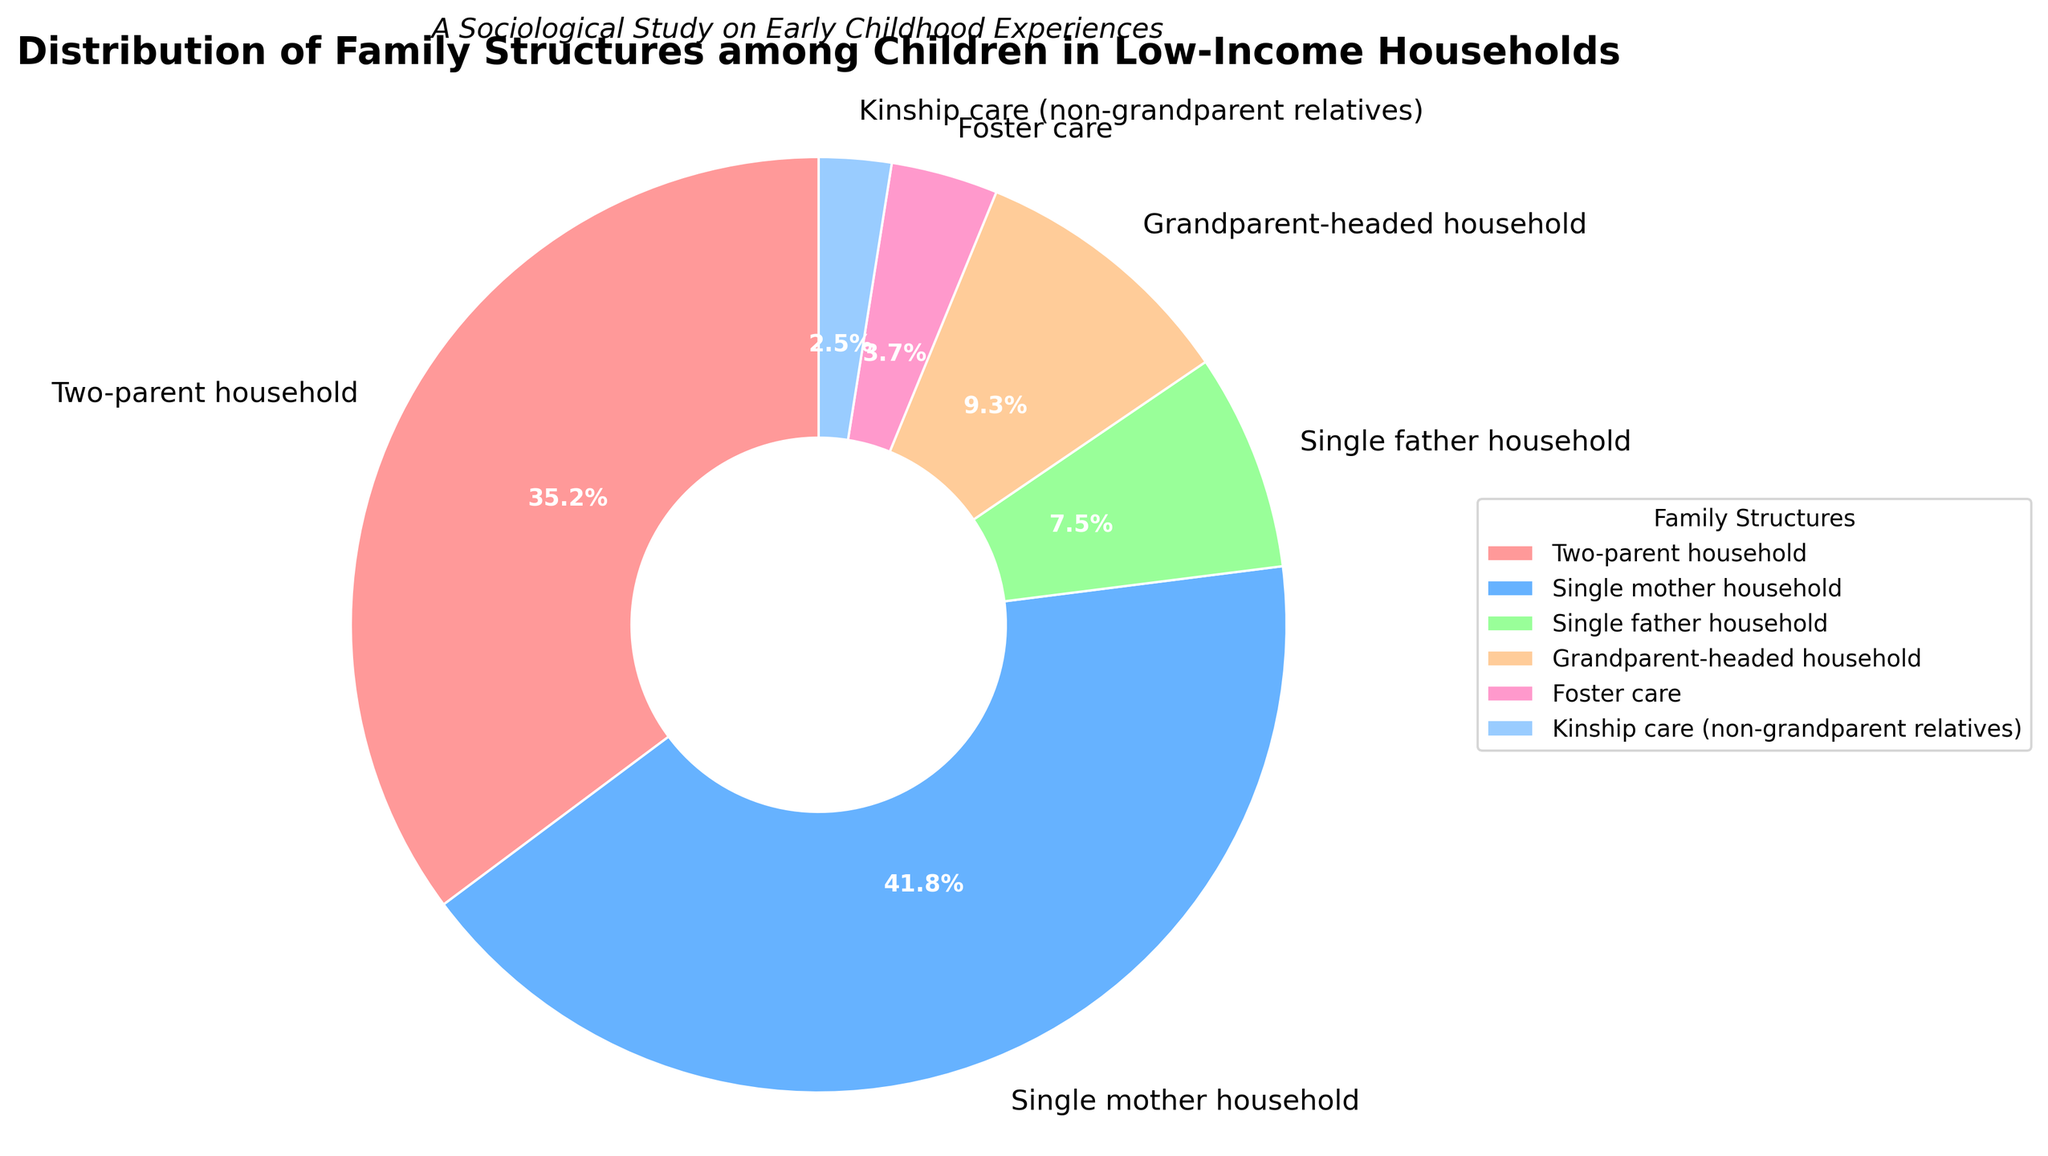What percentage of children live in single-parent households (combining single mother and single father households)? Combine the percentages of single mother households and single father households. 41.8% + 7.5% = 49.3%
Answer: 49.3% Which family structure has the largest proportion of children? Identify the family structure with the highest percentage. Single mother household has 41.8%, which is the largest.
Answer: Single mother household How many times larger is the proportion of children in grandparent-headed households compared to kinship care (non-grandparent relatives)? Divide the percentage of grandparent-headed households by the percentage of kinship care: 9.3% / 2.5% = 3.72
Answer: 3.72 times Which family structure has the smallest proportion, and what is it? Identify the family structure with the lowest percentage. Kinship care has the smallest proportion of 2.5%.
Answer: Kinship care, 2.5% What percentage of children live in either grandparent-headed households or foster care? Add the percentages of grandparent-headed households and foster care: 9.3% + 3.7% = 13.0%
Answer: 13.0% Compare the summed percentage of children in two-parent households with those in single mother households. Which group is larger and by how much? Subtract the percentage of two-parent households from the percentage of single mother households: 41.8% - 35.2% = 6.6%. Single mother households have a larger percentage by 6.6%.
Answer: Single mother households, 6.6% What is the difference in percentage between children in single mother households and those in single father households? Subtract the percentage of single father households from that of single mother households: 41.8% - 7.5% = 34.3%
Answer: 34.3% Which family structure is represented by the light blue color, and what is its percentage? Identify the light blue segment in the pie chart, which corresponds to single father households with 7.5%.
Answer: Single father households, 7.5% What is the total percentage of children in non-nuclear family structures (single parent, grandparent-headed, foster care, kinship care)? Add the percentages of single mother households, single father households, grandparent-headed households, foster care, and kinship care: 41.8% + 7.5% + 9.3% + 3.7% + 2.5% = 64.8%
Answer: 64.8% If you exclude single parent households, what percentage of children live in other family structures? Subtract the summed percentage of single parent households from 100%: 100% - (41.8% + 7.5%) = 50.7%
Answer: 50.7% 